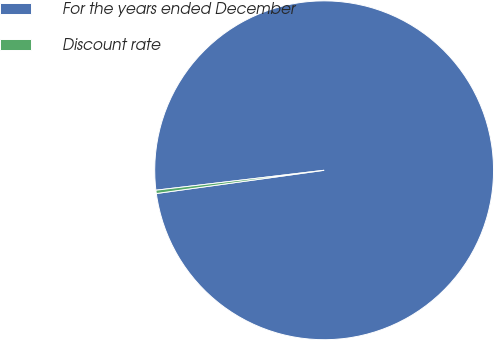Convert chart. <chart><loc_0><loc_0><loc_500><loc_500><pie_chart><fcel>For the years ended December<fcel>Discount rate<nl><fcel>99.69%<fcel>0.31%<nl></chart> 